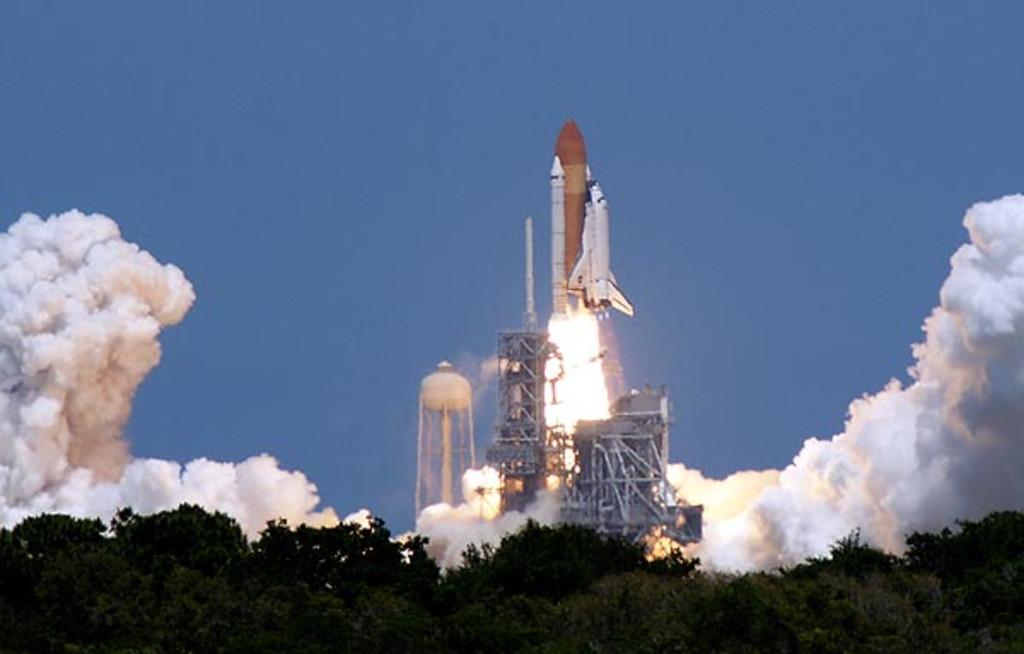What is the main subject in the center of the image? There is a rocket in the center of the image. What other structures can be seen in the image? There are towers in the image. What type of animal is present in the image? A dog is coming out in the image. What type of vegetation is at the bottom of the image? There are trees at the bottom of the image. What is visible at the top of the image? The sky is visible at the top of the image. What is the income of the rocket in the image? The rocket is an inanimate object and does not have an income. 